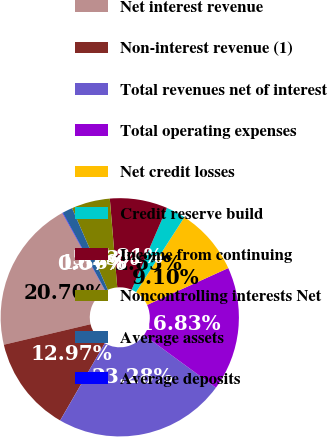Convert chart to OTSL. <chart><loc_0><loc_0><loc_500><loc_500><pie_chart><fcel>Net interest revenue<fcel>Non-interest revenue (1)<fcel>Total revenues net of interest<fcel>Total operating expenses<fcel>Net credit losses<fcel>Credit reserve build<fcel>Income from continuing<fcel>Noncontrolling interests Net<fcel>Average assets<fcel>Average deposits<nl><fcel>20.71%<fcel>12.97%<fcel>23.29%<fcel>16.84%<fcel>9.1%<fcel>2.65%<fcel>7.81%<fcel>5.23%<fcel>1.36%<fcel>0.07%<nl></chart> 